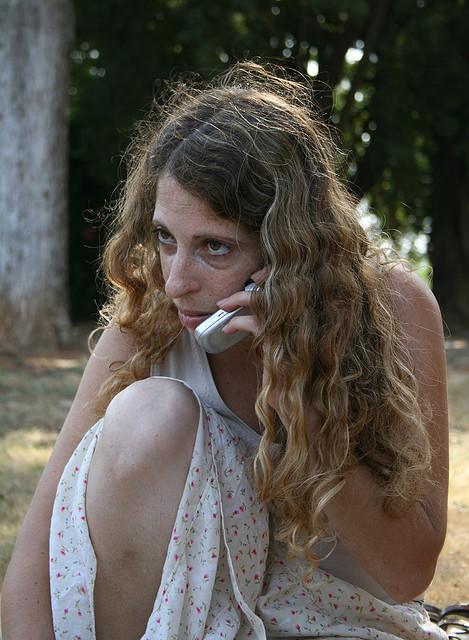Is this woman smiling?
Answer briefly. No. What style of phone is the woman using?
Short answer required. Cordless. Has the woman straightened her hair?
Give a very brief answer. No. 